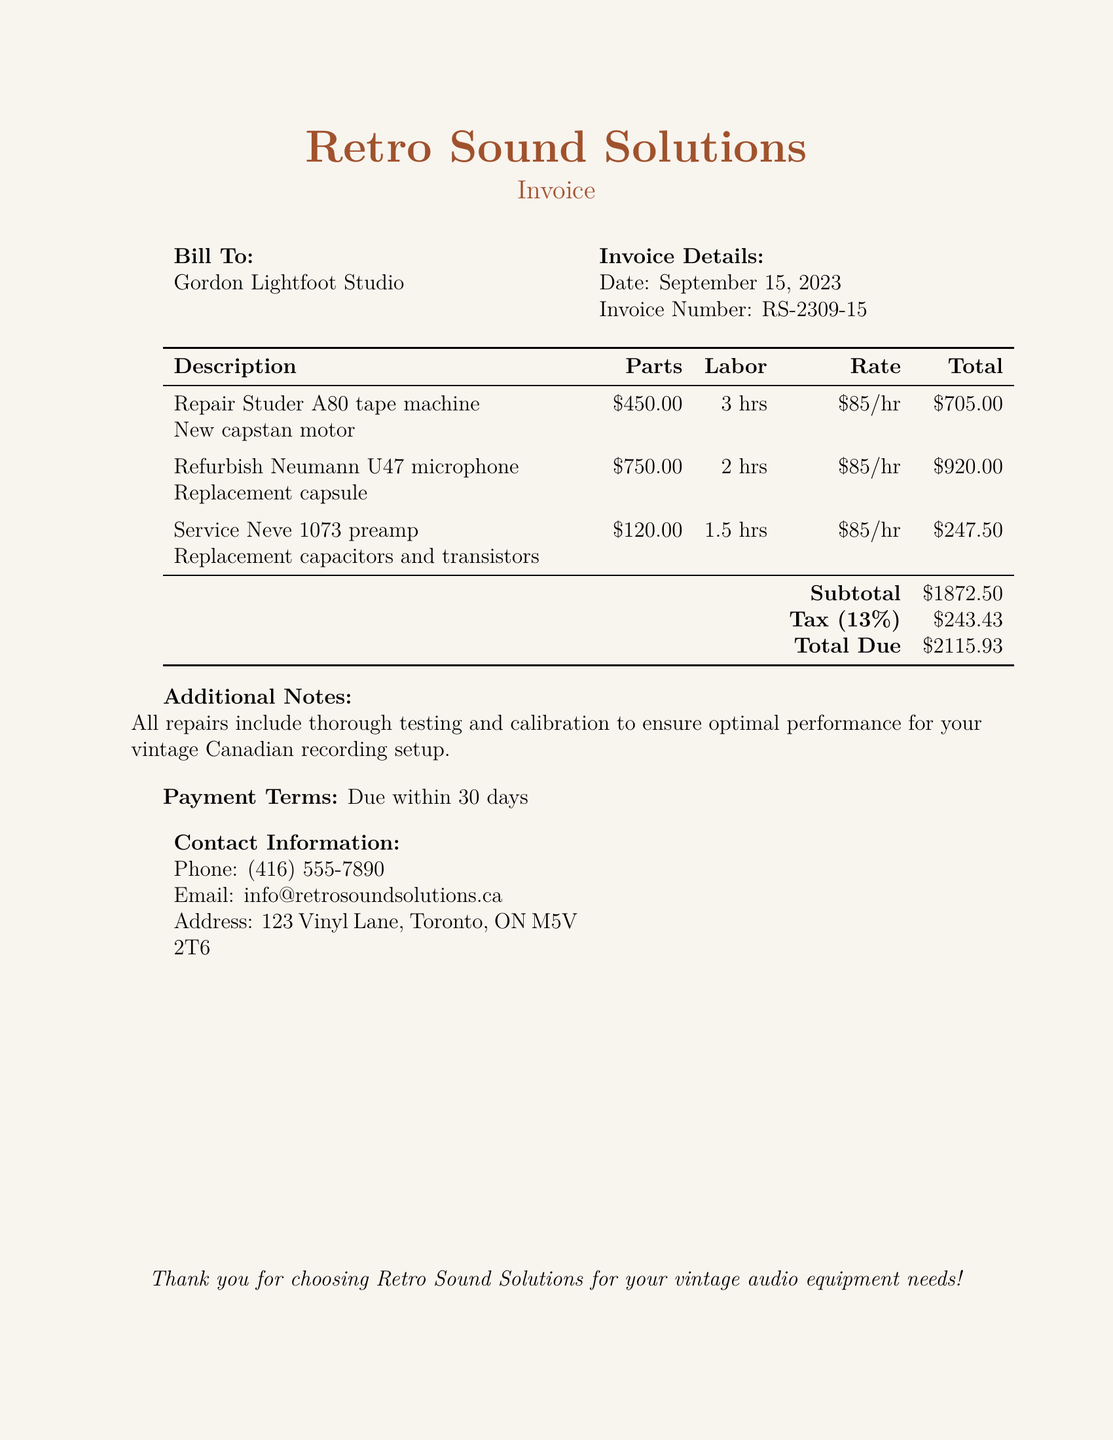What is the total due? The total due is calculated by adding the subtotal and tax, which amounts to $1872.50 + $243.43 = $2115.93.
Answer: $2115.93 What is the invoice number? The invoice number is a unique identifier for this bill, which is RS-2309-15.
Answer: RS-2309-15 How many hours of labor were required for the Neumann U47 microphone? The labor hours for the Neumann U47 microphone are listed in the bill as 2 hours.
Answer: 2 hrs What is the total cost for the Neve 1073 preamp service? The total cost for the Neve 1073 preamp service includes parts and labor, which adds up to $247.50.
Answer: $247.50 What is the tax percentage applied to the subtotal? The tax percentage applied to the subtotal is explicitly stated in the document as 13%.
Answer: 13% What type of equipment is mentioned in the first line item? The first line item specifies the type of equipment as a Studer A80 tape machine.
Answer: Studer A80 tape machine What is the benefit of the repairs included in the invoice? The document mentions that all repairs include thorough testing and calibration for optimal performance.
Answer: Thorough testing and calibration What is the due date for payment? The payment terms state that payment is due within 30 days from the invoice date.
Answer: Within 30 days What is the total amount for labor across all items? To find the total labor cost, you sum the labor hours multiplied by the hourly rate for each item, totaling $1447.50.
Answer: $1447.50 